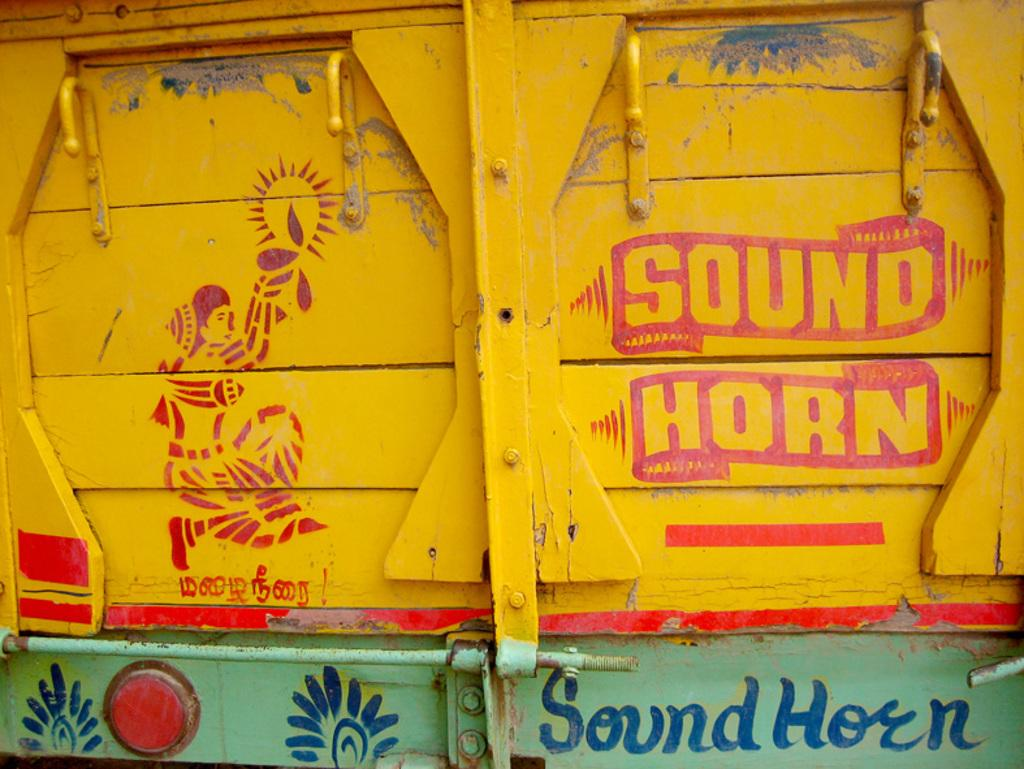What is the main subject of the image? There is a painting in the image. What else can be seen on the wooden surface in the image? There is information on a wooden surface in the image. What type of hardware is visible in the image? There are hooks and a bolt visible in the image. What can be inferred about the setting of the image? The image appears to be a partial part of a vehicle. What type of offer is the giraffe making to the dad in the image? There is no giraffe or dad present in the image, so no such offer can be observed. 